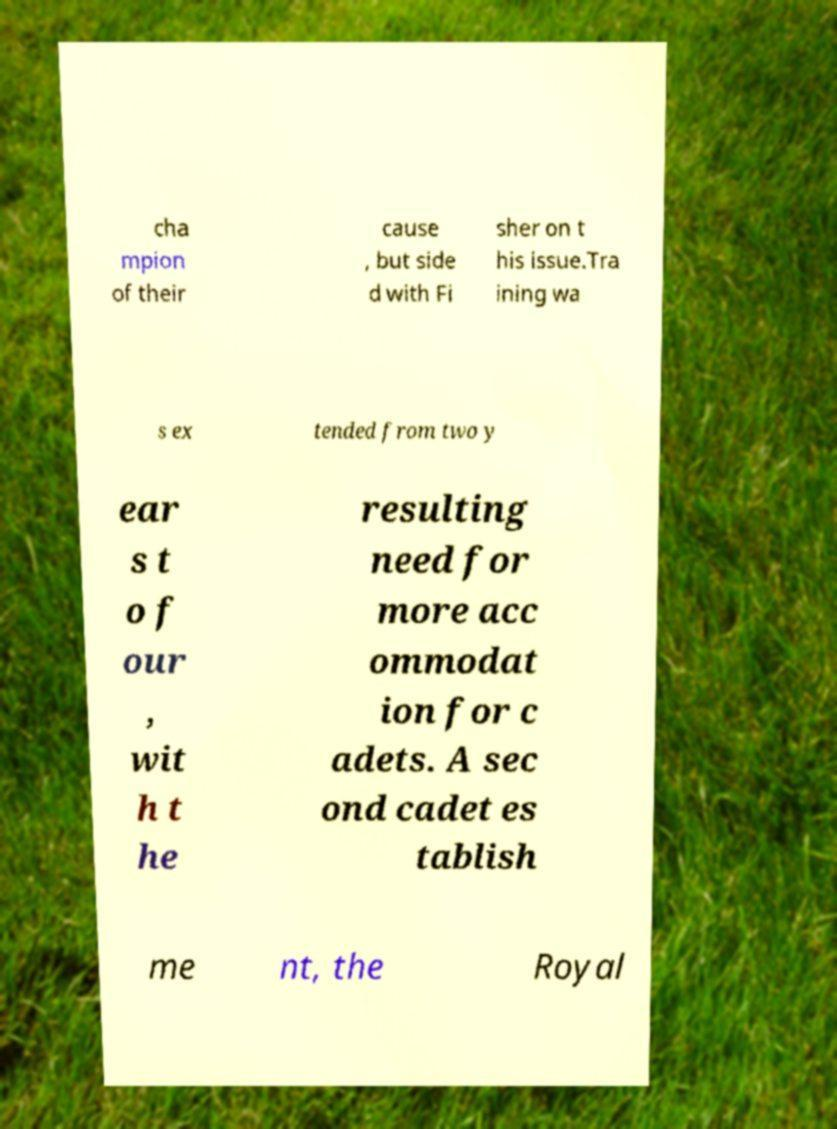Can you accurately transcribe the text from the provided image for me? cha mpion of their cause , but side d with Fi sher on t his issue.Tra ining wa s ex tended from two y ear s t o f our , wit h t he resulting need for more acc ommodat ion for c adets. A sec ond cadet es tablish me nt, the Royal 